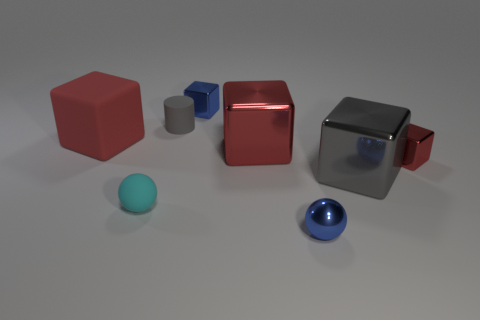What do you think this arrangement of objects is meant to represent or be used for? This image seems to be a setup for either a visual study of geometrical shapes and reflections or an artistic composition. The variety in shapes, sizes, and colors could be meant to demonstrate shading and light interactions in a 3D rendering environment. 